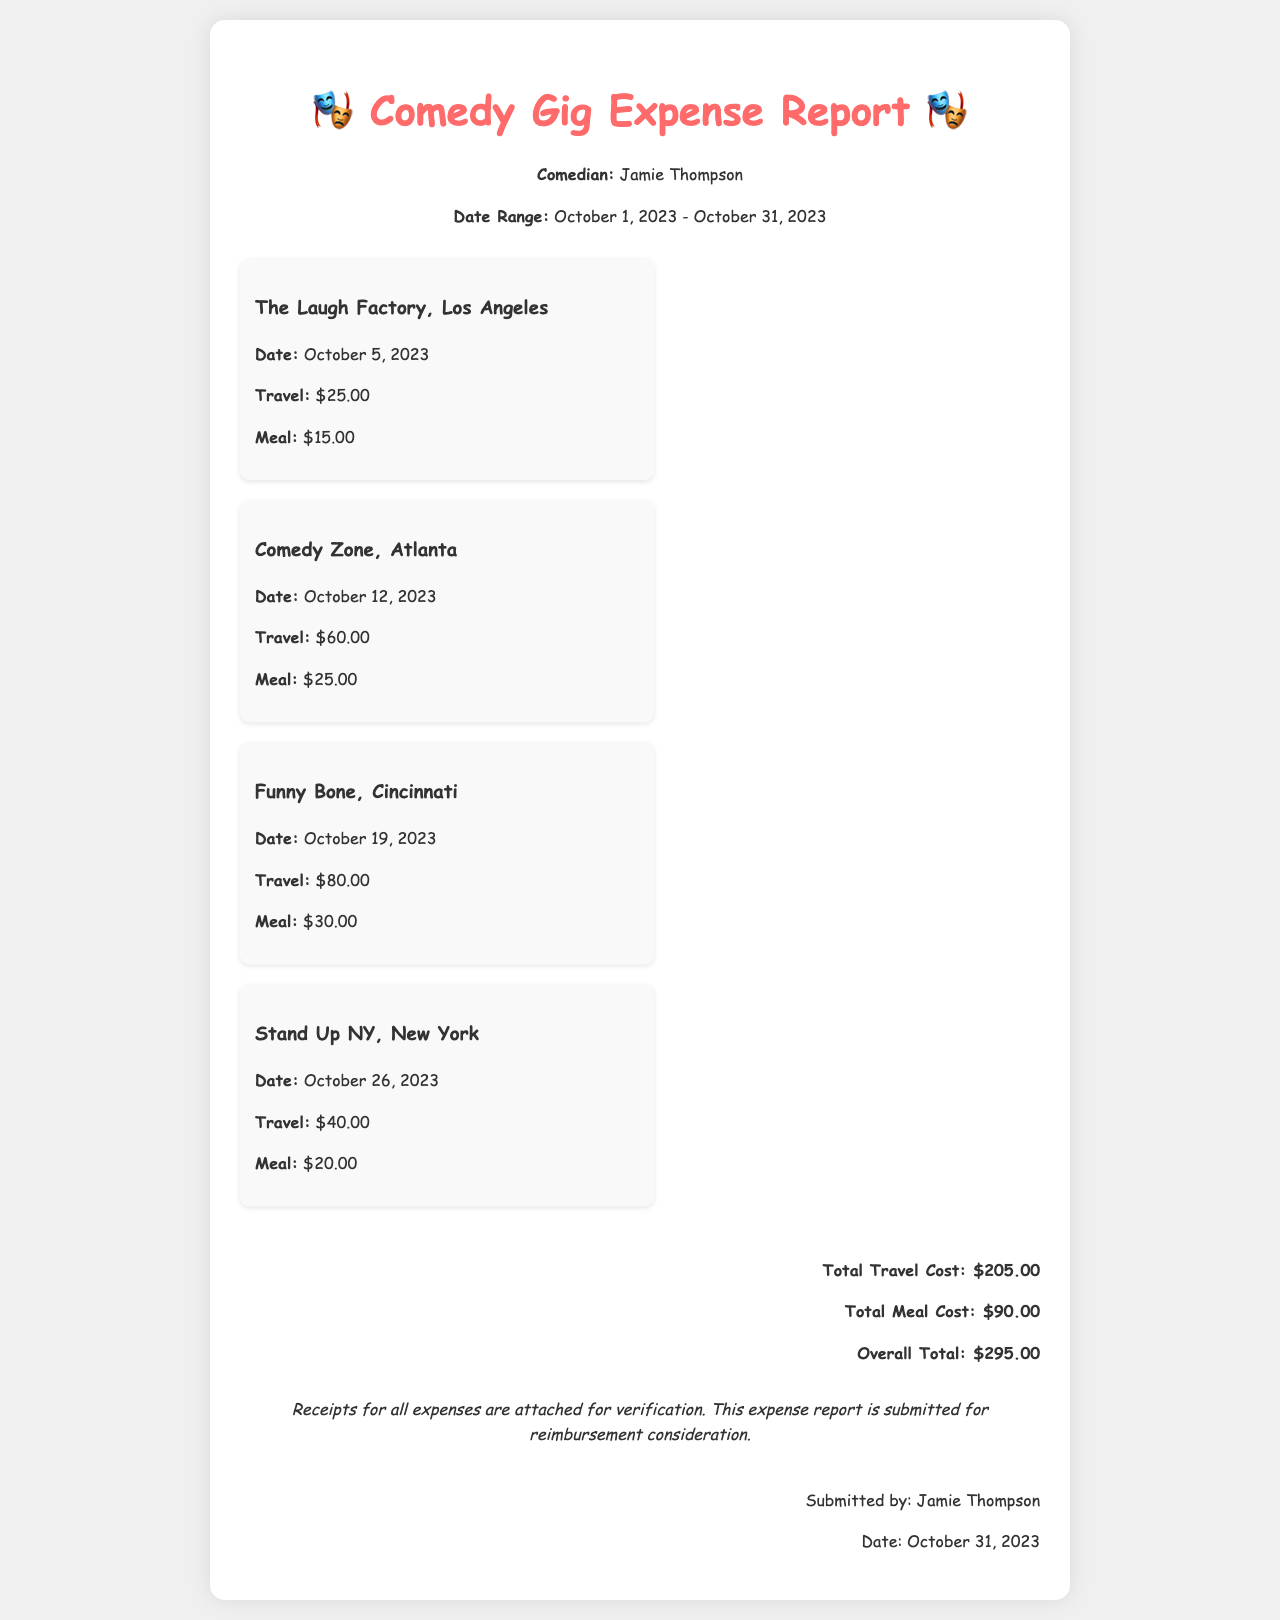What is the name of the comedian? The comedian's name is stated at the top of the document.
Answer: Jamie Thompson What is the date range of the expenses? The date range is provided in the header section of the document.
Answer: October 1, 2023 - October 31, 2023 How much was spent on meals in total? The total meal cost is summarized at the bottom of the document.
Answer: $90.00 Which gig incurred the highest travel cost? The travel costs are listed for each gig; the highest is compared.
Answer: Funny Bone, Cincinnati What is the total overall cost reported? The overall total is provided in the totals section of the document.
Answer: $295.00 What is the date of the gig at Comedy Zone? The date for the Comedy Zone gig is stated in its section.
Answer: October 12, 2023 What type of report is this document? The title of the document indicates its nature.
Answer: Expense Report How many gigs are listed in the report? The document lists the number of gigs under the "gig-list" section.
Answer: 4 What is noted about the receipts? The note section mentions information regarding the receipts.
Answer: Attached for verification 